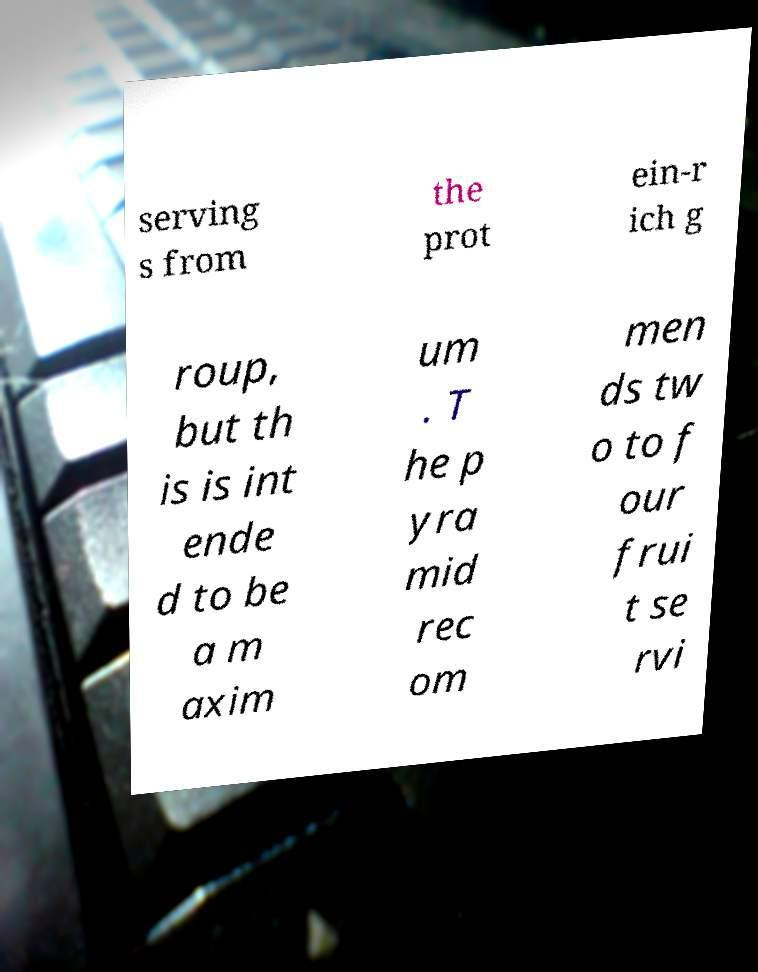What messages or text are displayed in this image? I need them in a readable, typed format. serving s from the prot ein-r ich g roup, but th is is int ende d to be a m axim um . T he p yra mid rec om men ds tw o to f our frui t se rvi 